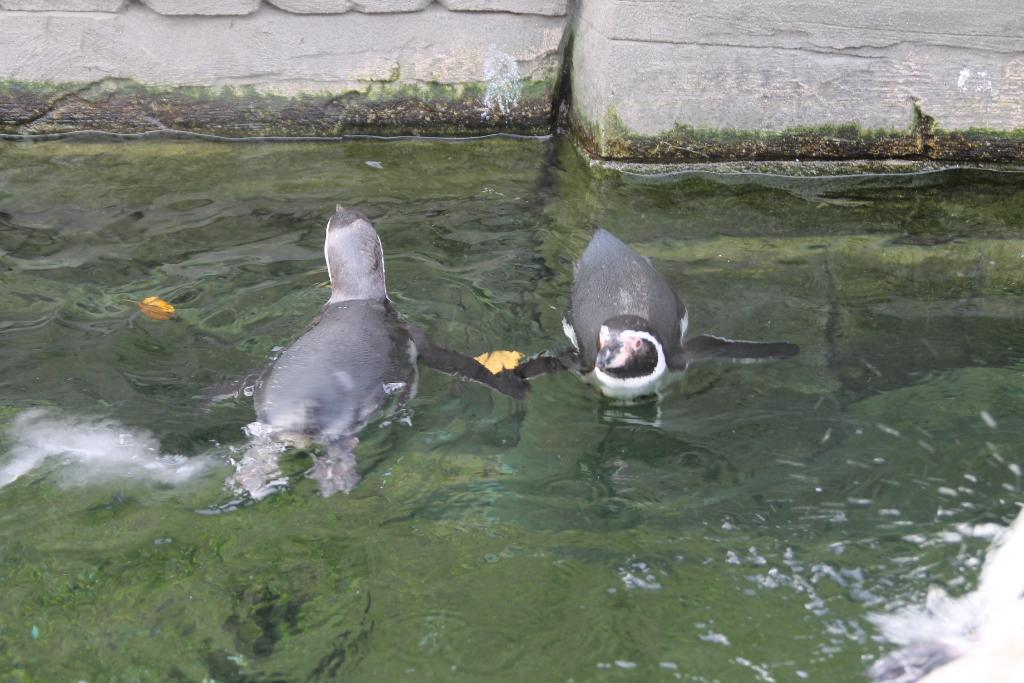What animals can be seen in the water at the center of the image? There are two dolphins in the water at the center of the image. What is visible in the background of the image? There is a wall in the background of the image. What letters are visible on the dolphins' bodies in the image? There are no letters visible on the dolphins' bodies in the image. 